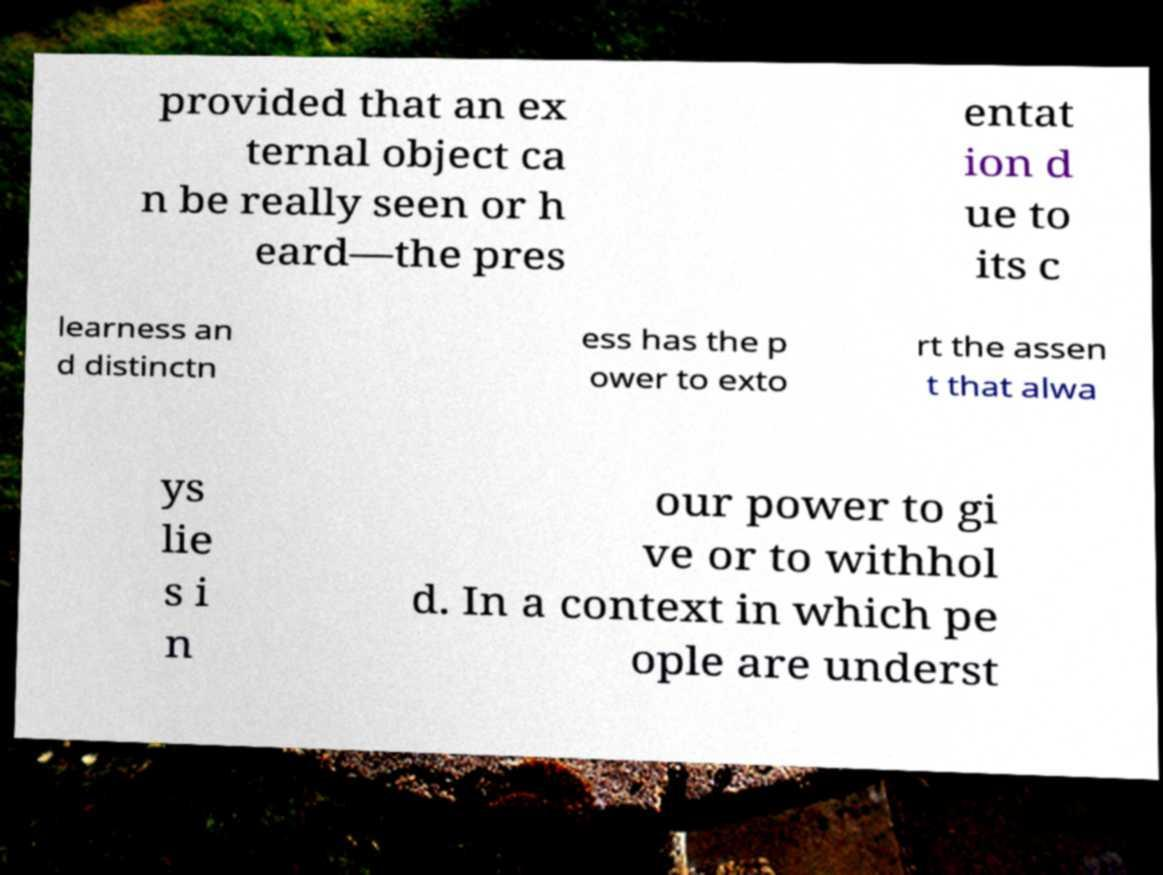Please identify and transcribe the text found in this image. provided that an ex ternal object ca n be really seen or h eard—the pres entat ion d ue to its c learness an d distinctn ess has the p ower to exto rt the assen t that alwa ys lie s i n our power to gi ve or to withhol d. In a context in which pe ople are underst 